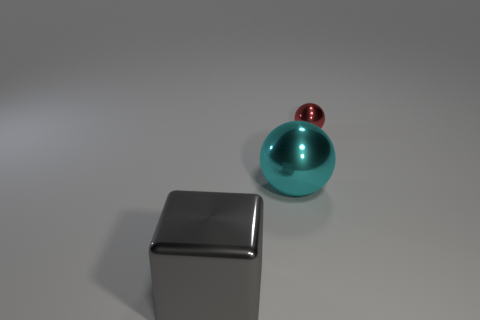Do the big ball and the ball that is behind the big cyan ball have the same material? It appears that both the large cyan ball and the smaller red ball positioned behind it exhibit a similar reflective quality, indicating that they might be made of the same or similar materials with a glossy finish, likely a type of polished metal or plastic. 